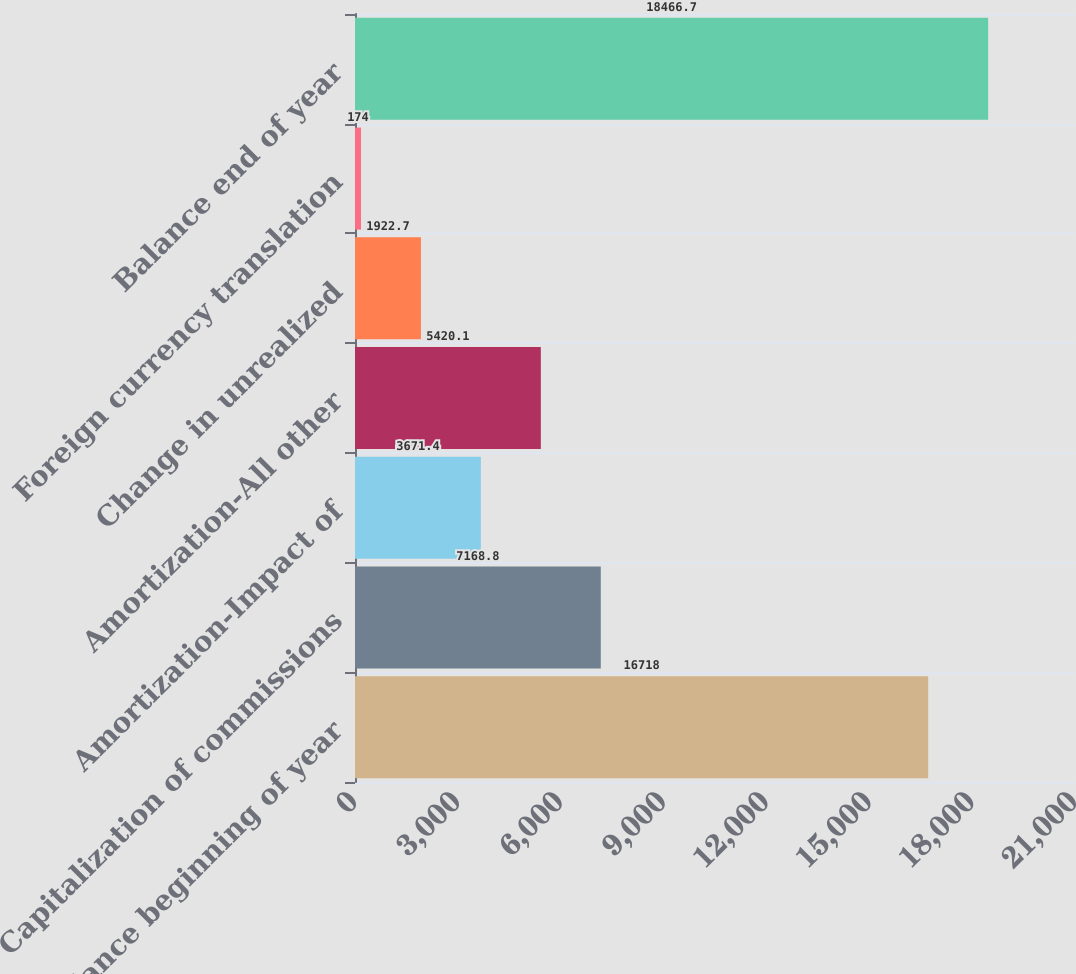<chart> <loc_0><loc_0><loc_500><loc_500><bar_chart><fcel>Balance beginning of year<fcel>Capitalization of commissions<fcel>Amortization-Impact of<fcel>Amortization-All other<fcel>Change in unrealized<fcel>Foreign currency translation<fcel>Balance end of year<nl><fcel>16718<fcel>7168.8<fcel>3671.4<fcel>5420.1<fcel>1922.7<fcel>174<fcel>18466.7<nl></chart> 